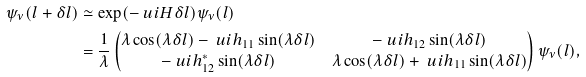<formula> <loc_0><loc_0><loc_500><loc_500>\psi _ { \nu } ( l + \delta l ) & \simeq \exp ( - \ u i H \delta l ) \psi _ { \nu } ( l ) \\ & = \frac { 1 } { \lambda } \begin{pmatrix} \lambda \cos ( \lambda \delta l ) - \ u i h _ { 1 1 } \sin ( \lambda \delta l ) & - \ u i h _ { 1 2 } \sin ( \lambda \delta l ) \\ - \ u i h _ { 1 2 } ^ { * } \sin ( \lambda \delta l ) & \lambda \cos ( \lambda \delta l ) + \ u i h _ { 1 1 } \sin ( \lambda \delta l ) \end{pmatrix} \psi _ { \nu } ( l ) ,</formula> 